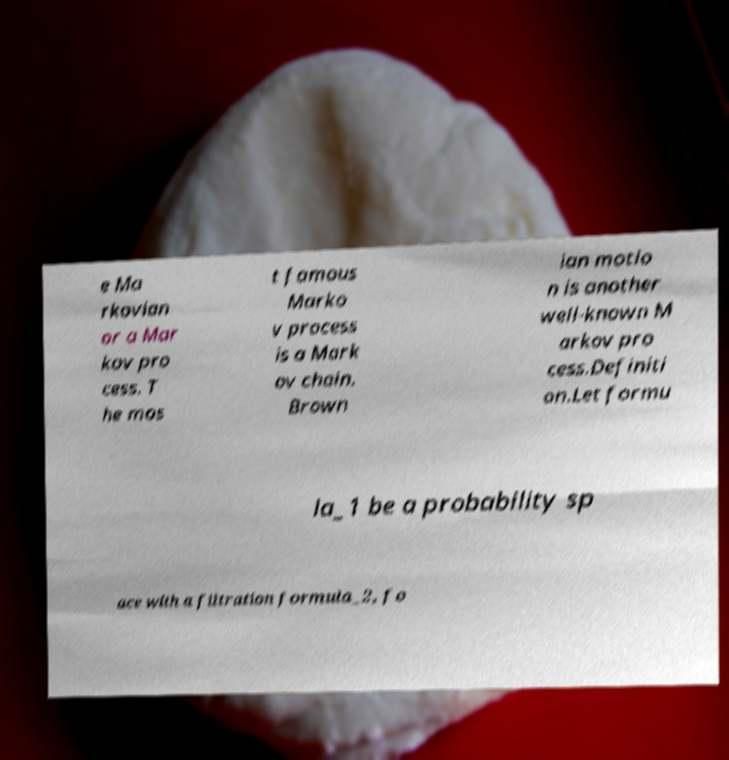Could you extract and type out the text from this image? e Ma rkovian or a Mar kov pro cess. T he mos t famous Marko v process is a Mark ov chain. Brown ian motio n is another well-known M arkov pro cess.Definiti on.Let formu la_1 be a probability sp ace with a filtration formula_2, fo 